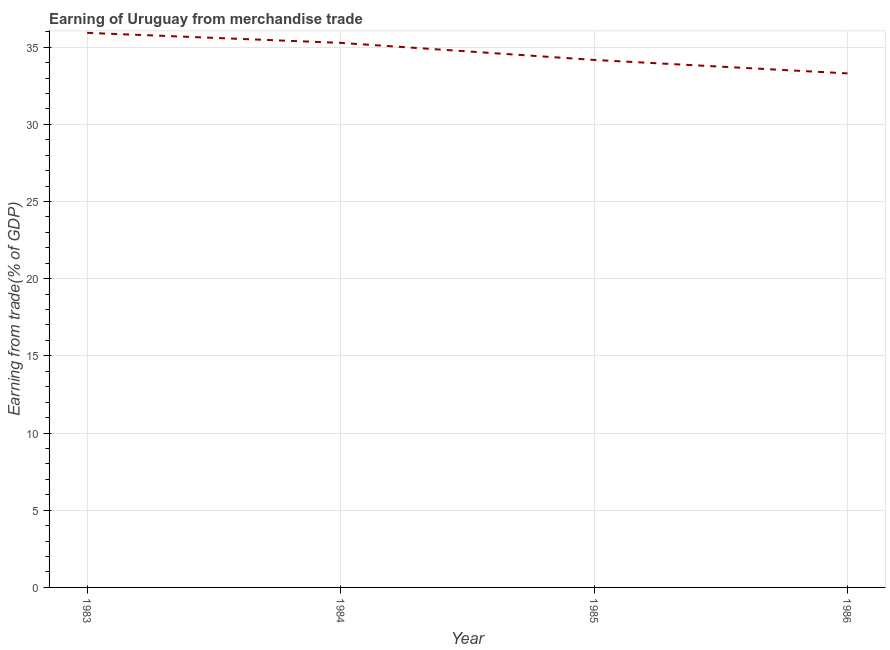What is the earning from merchandise trade in 1986?
Your answer should be compact. 33.3. Across all years, what is the maximum earning from merchandise trade?
Offer a very short reply. 35.93. Across all years, what is the minimum earning from merchandise trade?
Offer a terse response. 33.3. In which year was the earning from merchandise trade maximum?
Offer a very short reply. 1983. What is the sum of the earning from merchandise trade?
Make the answer very short. 138.67. What is the difference between the earning from merchandise trade in 1983 and 1984?
Make the answer very short. 0.65. What is the average earning from merchandise trade per year?
Provide a short and direct response. 34.67. What is the median earning from merchandise trade?
Offer a terse response. 34.72. In how many years, is the earning from merchandise trade greater than 14 %?
Give a very brief answer. 4. What is the ratio of the earning from merchandise trade in 1983 to that in 1984?
Your answer should be compact. 1.02. Is the earning from merchandise trade in 1983 less than that in 1986?
Your response must be concise. No. What is the difference between the highest and the second highest earning from merchandise trade?
Ensure brevity in your answer.  0.65. Is the sum of the earning from merchandise trade in 1985 and 1986 greater than the maximum earning from merchandise trade across all years?
Offer a terse response. Yes. What is the difference between the highest and the lowest earning from merchandise trade?
Ensure brevity in your answer.  2.63. Does the earning from merchandise trade monotonically increase over the years?
Offer a very short reply. No. How many lines are there?
Make the answer very short. 1. What is the difference between two consecutive major ticks on the Y-axis?
Your response must be concise. 5. What is the title of the graph?
Your response must be concise. Earning of Uruguay from merchandise trade. What is the label or title of the Y-axis?
Offer a terse response. Earning from trade(% of GDP). What is the Earning from trade(% of GDP) in 1983?
Provide a short and direct response. 35.93. What is the Earning from trade(% of GDP) in 1984?
Offer a very short reply. 35.28. What is the Earning from trade(% of GDP) in 1985?
Your answer should be very brief. 34.17. What is the Earning from trade(% of GDP) of 1986?
Your answer should be very brief. 33.3. What is the difference between the Earning from trade(% of GDP) in 1983 and 1984?
Ensure brevity in your answer.  0.65. What is the difference between the Earning from trade(% of GDP) in 1983 and 1985?
Provide a succinct answer. 1.75. What is the difference between the Earning from trade(% of GDP) in 1983 and 1986?
Your answer should be very brief. 2.63. What is the difference between the Earning from trade(% of GDP) in 1984 and 1985?
Ensure brevity in your answer.  1.11. What is the difference between the Earning from trade(% of GDP) in 1984 and 1986?
Give a very brief answer. 1.98. What is the difference between the Earning from trade(% of GDP) in 1985 and 1986?
Ensure brevity in your answer.  0.87. What is the ratio of the Earning from trade(% of GDP) in 1983 to that in 1985?
Your answer should be very brief. 1.05. What is the ratio of the Earning from trade(% of GDP) in 1983 to that in 1986?
Offer a very short reply. 1.08. What is the ratio of the Earning from trade(% of GDP) in 1984 to that in 1985?
Your answer should be compact. 1.03. What is the ratio of the Earning from trade(% of GDP) in 1984 to that in 1986?
Provide a short and direct response. 1.06. What is the ratio of the Earning from trade(% of GDP) in 1985 to that in 1986?
Your answer should be compact. 1.03. 